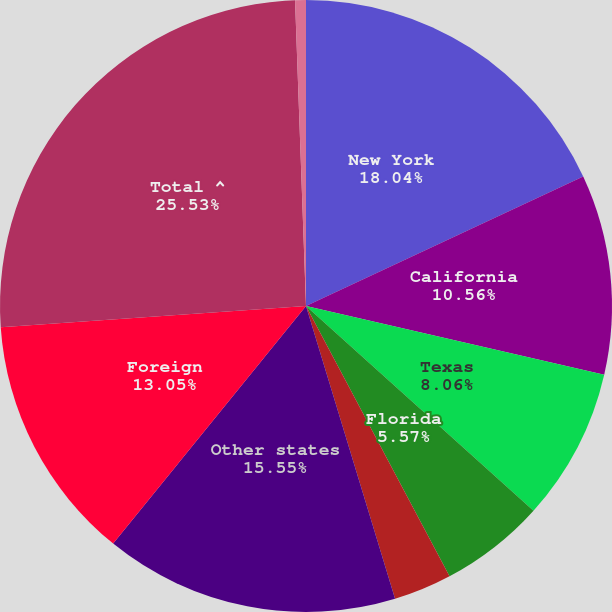Convert chart. <chart><loc_0><loc_0><loc_500><loc_500><pie_chart><fcel>New York<fcel>California<fcel>Texas<fcel>Florida<fcel>Illinois<fcel>Other states<fcel>Foreign<fcel>Total ^<fcel>Pennsylvania<nl><fcel>18.04%<fcel>10.56%<fcel>8.06%<fcel>5.57%<fcel>3.07%<fcel>15.55%<fcel>13.05%<fcel>25.53%<fcel>0.57%<nl></chart> 